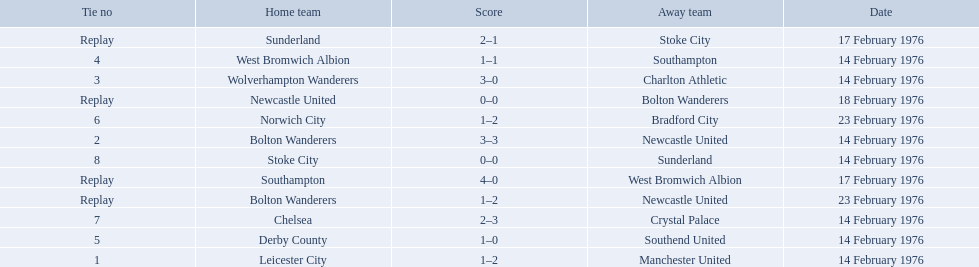Who were all the teams that played? Leicester City, Manchester United, Bolton Wanderers, Newcastle United, Newcastle United, Bolton Wanderers, Bolton Wanderers, Newcastle United, Wolverhampton Wanderers, Charlton Athletic, West Bromwich Albion, Southampton, Southampton, West Bromwich Albion, Derby County, Southend United, Norwich City, Bradford City, Chelsea, Crystal Palace, Stoke City, Sunderland, Sunderland, Stoke City. Which of these teams won? Manchester United, Newcastle United, Wolverhampton Wanderers, Southampton, Derby County, Bradford City, Crystal Palace, Sunderland. What was manchester united's winning score? 1–2. What was the wolverhampton wonders winning score? 3–0. Which of these two teams had the better winning score? Wolverhampton Wanderers. 